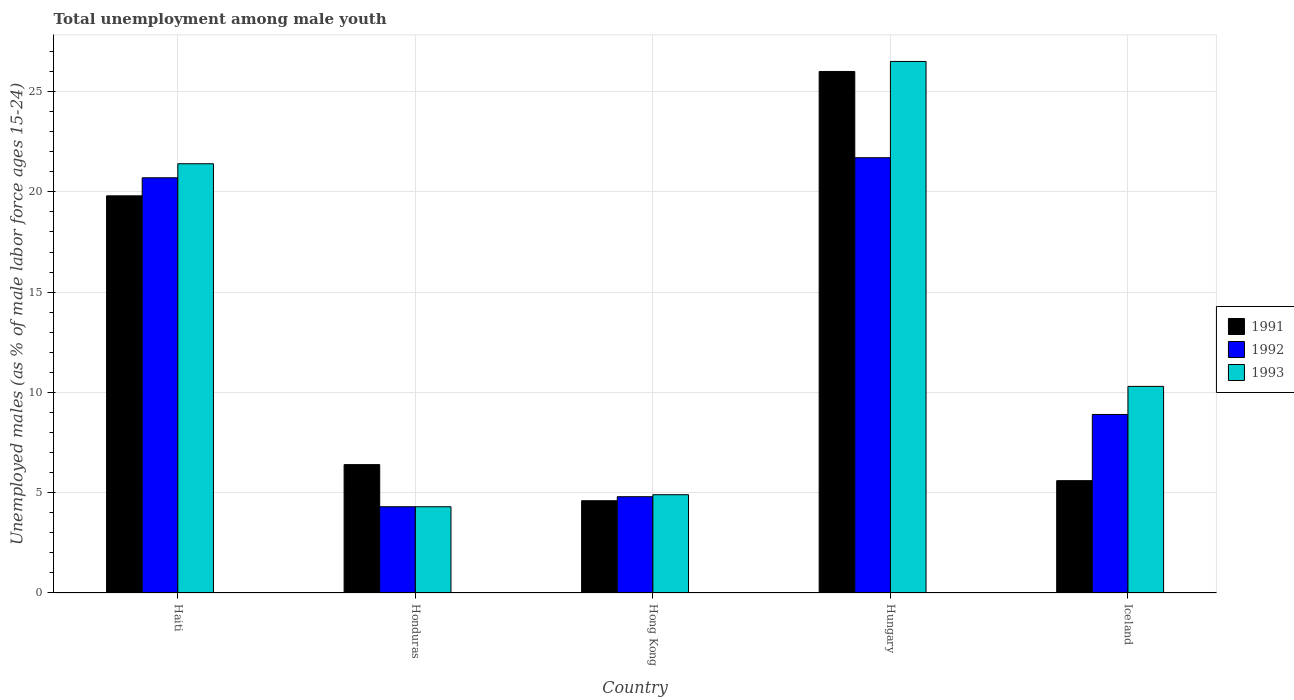How many groups of bars are there?
Offer a very short reply. 5. Are the number of bars on each tick of the X-axis equal?
Offer a terse response. Yes. How many bars are there on the 4th tick from the left?
Provide a succinct answer. 3. How many bars are there on the 5th tick from the right?
Offer a very short reply. 3. What is the label of the 4th group of bars from the left?
Your response must be concise. Hungary. In how many cases, is the number of bars for a given country not equal to the number of legend labels?
Give a very brief answer. 0. Across all countries, what is the maximum percentage of unemployed males in in 1992?
Ensure brevity in your answer.  21.7. Across all countries, what is the minimum percentage of unemployed males in in 1991?
Offer a terse response. 4.6. In which country was the percentage of unemployed males in in 1992 maximum?
Provide a short and direct response. Hungary. In which country was the percentage of unemployed males in in 1993 minimum?
Provide a succinct answer. Honduras. What is the total percentage of unemployed males in in 1992 in the graph?
Offer a very short reply. 60.4. What is the difference between the percentage of unemployed males in in 1993 in Honduras and that in Hong Kong?
Offer a terse response. -0.6. What is the difference between the percentage of unemployed males in in 1992 in Hungary and the percentage of unemployed males in in 1991 in Hong Kong?
Give a very brief answer. 17.1. What is the average percentage of unemployed males in in 1993 per country?
Offer a very short reply. 13.48. What is the difference between the percentage of unemployed males in of/in 1993 and percentage of unemployed males in of/in 1992 in Hungary?
Provide a short and direct response. 4.8. What is the ratio of the percentage of unemployed males in in 1992 in Honduras to that in Hong Kong?
Keep it short and to the point. 0.9. Is the percentage of unemployed males in in 1993 in Haiti less than that in Hungary?
Ensure brevity in your answer.  Yes. Is the difference between the percentage of unemployed males in in 1993 in Haiti and Hong Kong greater than the difference between the percentage of unemployed males in in 1992 in Haiti and Hong Kong?
Your response must be concise. Yes. What is the difference between the highest and the second highest percentage of unemployed males in in 1991?
Make the answer very short. 6.2. What is the difference between the highest and the lowest percentage of unemployed males in in 1992?
Offer a very short reply. 17.4. Is the sum of the percentage of unemployed males in in 1993 in Hong Kong and Iceland greater than the maximum percentage of unemployed males in in 1991 across all countries?
Ensure brevity in your answer.  No. What does the 1st bar from the left in Hong Kong represents?
Offer a terse response. 1991. Is it the case that in every country, the sum of the percentage of unemployed males in in 1991 and percentage of unemployed males in in 1992 is greater than the percentage of unemployed males in in 1993?
Ensure brevity in your answer.  Yes. How are the legend labels stacked?
Offer a very short reply. Vertical. What is the title of the graph?
Offer a very short reply. Total unemployment among male youth. What is the label or title of the Y-axis?
Offer a very short reply. Unemployed males (as % of male labor force ages 15-24). What is the Unemployed males (as % of male labor force ages 15-24) of 1991 in Haiti?
Provide a succinct answer. 19.8. What is the Unemployed males (as % of male labor force ages 15-24) in 1992 in Haiti?
Keep it short and to the point. 20.7. What is the Unemployed males (as % of male labor force ages 15-24) of 1993 in Haiti?
Provide a succinct answer. 21.4. What is the Unemployed males (as % of male labor force ages 15-24) in 1991 in Honduras?
Offer a terse response. 6.4. What is the Unemployed males (as % of male labor force ages 15-24) of 1992 in Honduras?
Your answer should be compact. 4.3. What is the Unemployed males (as % of male labor force ages 15-24) of 1993 in Honduras?
Give a very brief answer. 4.3. What is the Unemployed males (as % of male labor force ages 15-24) in 1991 in Hong Kong?
Offer a terse response. 4.6. What is the Unemployed males (as % of male labor force ages 15-24) in 1992 in Hong Kong?
Offer a terse response. 4.8. What is the Unemployed males (as % of male labor force ages 15-24) of 1993 in Hong Kong?
Give a very brief answer. 4.9. What is the Unemployed males (as % of male labor force ages 15-24) in 1992 in Hungary?
Make the answer very short. 21.7. What is the Unemployed males (as % of male labor force ages 15-24) in 1991 in Iceland?
Offer a terse response. 5.6. What is the Unemployed males (as % of male labor force ages 15-24) in 1992 in Iceland?
Your answer should be compact. 8.9. What is the Unemployed males (as % of male labor force ages 15-24) in 1993 in Iceland?
Ensure brevity in your answer.  10.3. Across all countries, what is the maximum Unemployed males (as % of male labor force ages 15-24) in 1991?
Provide a succinct answer. 26. Across all countries, what is the maximum Unemployed males (as % of male labor force ages 15-24) of 1992?
Your answer should be very brief. 21.7. Across all countries, what is the maximum Unemployed males (as % of male labor force ages 15-24) in 1993?
Give a very brief answer. 26.5. Across all countries, what is the minimum Unemployed males (as % of male labor force ages 15-24) in 1991?
Your answer should be compact. 4.6. Across all countries, what is the minimum Unemployed males (as % of male labor force ages 15-24) in 1992?
Your answer should be very brief. 4.3. Across all countries, what is the minimum Unemployed males (as % of male labor force ages 15-24) in 1993?
Offer a terse response. 4.3. What is the total Unemployed males (as % of male labor force ages 15-24) in 1991 in the graph?
Offer a terse response. 62.4. What is the total Unemployed males (as % of male labor force ages 15-24) in 1992 in the graph?
Your answer should be compact. 60.4. What is the total Unemployed males (as % of male labor force ages 15-24) of 1993 in the graph?
Ensure brevity in your answer.  67.4. What is the difference between the Unemployed males (as % of male labor force ages 15-24) in 1992 in Haiti and that in Honduras?
Make the answer very short. 16.4. What is the difference between the Unemployed males (as % of male labor force ages 15-24) of 1991 in Haiti and that in Hong Kong?
Offer a very short reply. 15.2. What is the difference between the Unemployed males (as % of male labor force ages 15-24) of 1992 in Haiti and that in Hong Kong?
Offer a very short reply. 15.9. What is the difference between the Unemployed males (as % of male labor force ages 15-24) of 1991 in Haiti and that in Hungary?
Keep it short and to the point. -6.2. What is the difference between the Unemployed males (as % of male labor force ages 15-24) of 1991 in Haiti and that in Iceland?
Provide a succinct answer. 14.2. What is the difference between the Unemployed males (as % of male labor force ages 15-24) in 1992 in Haiti and that in Iceland?
Offer a terse response. 11.8. What is the difference between the Unemployed males (as % of male labor force ages 15-24) of 1991 in Honduras and that in Hong Kong?
Ensure brevity in your answer.  1.8. What is the difference between the Unemployed males (as % of male labor force ages 15-24) of 1992 in Honduras and that in Hong Kong?
Your answer should be very brief. -0.5. What is the difference between the Unemployed males (as % of male labor force ages 15-24) of 1991 in Honduras and that in Hungary?
Offer a terse response. -19.6. What is the difference between the Unemployed males (as % of male labor force ages 15-24) in 1992 in Honduras and that in Hungary?
Ensure brevity in your answer.  -17.4. What is the difference between the Unemployed males (as % of male labor force ages 15-24) in 1993 in Honduras and that in Hungary?
Give a very brief answer. -22.2. What is the difference between the Unemployed males (as % of male labor force ages 15-24) of 1992 in Honduras and that in Iceland?
Your answer should be very brief. -4.6. What is the difference between the Unemployed males (as % of male labor force ages 15-24) in 1993 in Honduras and that in Iceland?
Your answer should be very brief. -6. What is the difference between the Unemployed males (as % of male labor force ages 15-24) of 1991 in Hong Kong and that in Hungary?
Your response must be concise. -21.4. What is the difference between the Unemployed males (as % of male labor force ages 15-24) in 1992 in Hong Kong and that in Hungary?
Keep it short and to the point. -16.9. What is the difference between the Unemployed males (as % of male labor force ages 15-24) in 1993 in Hong Kong and that in Hungary?
Your answer should be compact. -21.6. What is the difference between the Unemployed males (as % of male labor force ages 15-24) in 1991 in Hong Kong and that in Iceland?
Your answer should be compact. -1. What is the difference between the Unemployed males (as % of male labor force ages 15-24) in 1991 in Hungary and that in Iceland?
Keep it short and to the point. 20.4. What is the difference between the Unemployed males (as % of male labor force ages 15-24) in 1992 in Hungary and that in Iceland?
Your answer should be very brief. 12.8. What is the difference between the Unemployed males (as % of male labor force ages 15-24) of 1993 in Hungary and that in Iceland?
Your answer should be very brief. 16.2. What is the difference between the Unemployed males (as % of male labor force ages 15-24) of 1991 in Haiti and the Unemployed males (as % of male labor force ages 15-24) of 1993 in Honduras?
Your response must be concise. 15.5. What is the difference between the Unemployed males (as % of male labor force ages 15-24) of 1992 in Haiti and the Unemployed males (as % of male labor force ages 15-24) of 1993 in Honduras?
Offer a very short reply. 16.4. What is the difference between the Unemployed males (as % of male labor force ages 15-24) in 1991 in Haiti and the Unemployed males (as % of male labor force ages 15-24) in 1993 in Hong Kong?
Give a very brief answer. 14.9. What is the difference between the Unemployed males (as % of male labor force ages 15-24) of 1992 in Haiti and the Unemployed males (as % of male labor force ages 15-24) of 1993 in Hong Kong?
Your answer should be compact. 15.8. What is the difference between the Unemployed males (as % of male labor force ages 15-24) of 1991 in Haiti and the Unemployed males (as % of male labor force ages 15-24) of 1993 in Hungary?
Your answer should be compact. -6.7. What is the difference between the Unemployed males (as % of male labor force ages 15-24) in 1991 in Haiti and the Unemployed males (as % of male labor force ages 15-24) in 1993 in Iceland?
Keep it short and to the point. 9.5. What is the difference between the Unemployed males (as % of male labor force ages 15-24) in 1992 in Honduras and the Unemployed males (as % of male labor force ages 15-24) in 1993 in Hong Kong?
Offer a very short reply. -0.6. What is the difference between the Unemployed males (as % of male labor force ages 15-24) of 1991 in Honduras and the Unemployed males (as % of male labor force ages 15-24) of 1992 in Hungary?
Make the answer very short. -15.3. What is the difference between the Unemployed males (as % of male labor force ages 15-24) of 1991 in Honduras and the Unemployed males (as % of male labor force ages 15-24) of 1993 in Hungary?
Your response must be concise. -20.1. What is the difference between the Unemployed males (as % of male labor force ages 15-24) in 1992 in Honduras and the Unemployed males (as % of male labor force ages 15-24) in 1993 in Hungary?
Offer a terse response. -22.2. What is the difference between the Unemployed males (as % of male labor force ages 15-24) of 1991 in Honduras and the Unemployed males (as % of male labor force ages 15-24) of 1992 in Iceland?
Keep it short and to the point. -2.5. What is the difference between the Unemployed males (as % of male labor force ages 15-24) in 1991 in Hong Kong and the Unemployed males (as % of male labor force ages 15-24) in 1992 in Hungary?
Make the answer very short. -17.1. What is the difference between the Unemployed males (as % of male labor force ages 15-24) of 1991 in Hong Kong and the Unemployed males (as % of male labor force ages 15-24) of 1993 in Hungary?
Offer a very short reply. -21.9. What is the difference between the Unemployed males (as % of male labor force ages 15-24) in 1992 in Hong Kong and the Unemployed males (as % of male labor force ages 15-24) in 1993 in Hungary?
Provide a short and direct response. -21.7. What is the difference between the Unemployed males (as % of male labor force ages 15-24) in 1991 in Hong Kong and the Unemployed males (as % of male labor force ages 15-24) in 1992 in Iceland?
Your answer should be compact. -4.3. What is the difference between the Unemployed males (as % of male labor force ages 15-24) in 1991 in Hong Kong and the Unemployed males (as % of male labor force ages 15-24) in 1993 in Iceland?
Your answer should be compact. -5.7. What is the difference between the Unemployed males (as % of male labor force ages 15-24) in 1991 in Hungary and the Unemployed males (as % of male labor force ages 15-24) in 1992 in Iceland?
Give a very brief answer. 17.1. What is the average Unemployed males (as % of male labor force ages 15-24) in 1991 per country?
Offer a very short reply. 12.48. What is the average Unemployed males (as % of male labor force ages 15-24) of 1992 per country?
Keep it short and to the point. 12.08. What is the average Unemployed males (as % of male labor force ages 15-24) in 1993 per country?
Offer a terse response. 13.48. What is the difference between the Unemployed males (as % of male labor force ages 15-24) in 1991 and Unemployed males (as % of male labor force ages 15-24) in 1993 in Haiti?
Give a very brief answer. -1.6. What is the difference between the Unemployed males (as % of male labor force ages 15-24) in 1992 and Unemployed males (as % of male labor force ages 15-24) in 1993 in Honduras?
Your answer should be compact. 0. What is the difference between the Unemployed males (as % of male labor force ages 15-24) in 1991 and Unemployed males (as % of male labor force ages 15-24) in 1993 in Hong Kong?
Ensure brevity in your answer.  -0.3. What is the difference between the Unemployed males (as % of male labor force ages 15-24) of 1991 and Unemployed males (as % of male labor force ages 15-24) of 1992 in Hungary?
Make the answer very short. 4.3. What is the difference between the Unemployed males (as % of male labor force ages 15-24) of 1991 and Unemployed males (as % of male labor force ages 15-24) of 1993 in Hungary?
Your answer should be compact. -0.5. What is the difference between the Unemployed males (as % of male labor force ages 15-24) of 1991 and Unemployed males (as % of male labor force ages 15-24) of 1993 in Iceland?
Provide a succinct answer. -4.7. What is the ratio of the Unemployed males (as % of male labor force ages 15-24) in 1991 in Haiti to that in Honduras?
Provide a succinct answer. 3.09. What is the ratio of the Unemployed males (as % of male labor force ages 15-24) in 1992 in Haiti to that in Honduras?
Ensure brevity in your answer.  4.81. What is the ratio of the Unemployed males (as % of male labor force ages 15-24) of 1993 in Haiti to that in Honduras?
Offer a very short reply. 4.98. What is the ratio of the Unemployed males (as % of male labor force ages 15-24) of 1991 in Haiti to that in Hong Kong?
Offer a terse response. 4.3. What is the ratio of the Unemployed males (as % of male labor force ages 15-24) of 1992 in Haiti to that in Hong Kong?
Your response must be concise. 4.31. What is the ratio of the Unemployed males (as % of male labor force ages 15-24) in 1993 in Haiti to that in Hong Kong?
Your answer should be compact. 4.37. What is the ratio of the Unemployed males (as % of male labor force ages 15-24) in 1991 in Haiti to that in Hungary?
Make the answer very short. 0.76. What is the ratio of the Unemployed males (as % of male labor force ages 15-24) in 1992 in Haiti to that in Hungary?
Provide a succinct answer. 0.95. What is the ratio of the Unemployed males (as % of male labor force ages 15-24) in 1993 in Haiti to that in Hungary?
Your answer should be very brief. 0.81. What is the ratio of the Unemployed males (as % of male labor force ages 15-24) in 1991 in Haiti to that in Iceland?
Your answer should be compact. 3.54. What is the ratio of the Unemployed males (as % of male labor force ages 15-24) of 1992 in Haiti to that in Iceland?
Provide a succinct answer. 2.33. What is the ratio of the Unemployed males (as % of male labor force ages 15-24) of 1993 in Haiti to that in Iceland?
Offer a very short reply. 2.08. What is the ratio of the Unemployed males (as % of male labor force ages 15-24) in 1991 in Honduras to that in Hong Kong?
Your answer should be very brief. 1.39. What is the ratio of the Unemployed males (as % of male labor force ages 15-24) in 1992 in Honduras to that in Hong Kong?
Make the answer very short. 0.9. What is the ratio of the Unemployed males (as % of male labor force ages 15-24) in 1993 in Honduras to that in Hong Kong?
Provide a short and direct response. 0.88. What is the ratio of the Unemployed males (as % of male labor force ages 15-24) of 1991 in Honduras to that in Hungary?
Make the answer very short. 0.25. What is the ratio of the Unemployed males (as % of male labor force ages 15-24) in 1992 in Honduras to that in Hungary?
Ensure brevity in your answer.  0.2. What is the ratio of the Unemployed males (as % of male labor force ages 15-24) in 1993 in Honduras to that in Hungary?
Offer a terse response. 0.16. What is the ratio of the Unemployed males (as % of male labor force ages 15-24) of 1991 in Honduras to that in Iceland?
Offer a terse response. 1.14. What is the ratio of the Unemployed males (as % of male labor force ages 15-24) of 1992 in Honduras to that in Iceland?
Give a very brief answer. 0.48. What is the ratio of the Unemployed males (as % of male labor force ages 15-24) in 1993 in Honduras to that in Iceland?
Offer a very short reply. 0.42. What is the ratio of the Unemployed males (as % of male labor force ages 15-24) of 1991 in Hong Kong to that in Hungary?
Your response must be concise. 0.18. What is the ratio of the Unemployed males (as % of male labor force ages 15-24) of 1992 in Hong Kong to that in Hungary?
Offer a very short reply. 0.22. What is the ratio of the Unemployed males (as % of male labor force ages 15-24) of 1993 in Hong Kong to that in Hungary?
Offer a terse response. 0.18. What is the ratio of the Unemployed males (as % of male labor force ages 15-24) in 1991 in Hong Kong to that in Iceland?
Ensure brevity in your answer.  0.82. What is the ratio of the Unemployed males (as % of male labor force ages 15-24) of 1992 in Hong Kong to that in Iceland?
Give a very brief answer. 0.54. What is the ratio of the Unemployed males (as % of male labor force ages 15-24) in 1993 in Hong Kong to that in Iceland?
Offer a terse response. 0.48. What is the ratio of the Unemployed males (as % of male labor force ages 15-24) of 1991 in Hungary to that in Iceland?
Make the answer very short. 4.64. What is the ratio of the Unemployed males (as % of male labor force ages 15-24) in 1992 in Hungary to that in Iceland?
Offer a terse response. 2.44. What is the ratio of the Unemployed males (as % of male labor force ages 15-24) in 1993 in Hungary to that in Iceland?
Your answer should be compact. 2.57. What is the difference between the highest and the second highest Unemployed males (as % of male labor force ages 15-24) of 1991?
Your answer should be compact. 6.2. What is the difference between the highest and the second highest Unemployed males (as % of male labor force ages 15-24) of 1992?
Provide a short and direct response. 1. What is the difference between the highest and the second highest Unemployed males (as % of male labor force ages 15-24) of 1993?
Provide a short and direct response. 5.1. What is the difference between the highest and the lowest Unemployed males (as % of male labor force ages 15-24) of 1991?
Offer a very short reply. 21.4. What is the difference between the highest and the lowest Unemployed males (as % of male labor force ages 15-24) in 1993?
Your answer should be very brief. 22.2. 